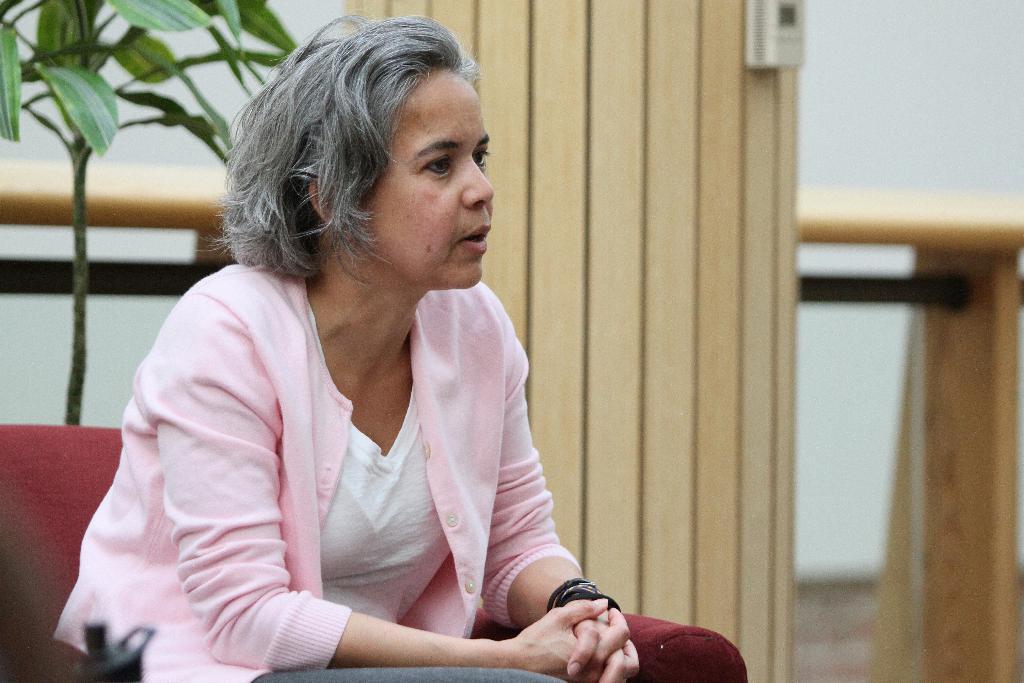Can you describe this image briefly? This is the woman sitting on the couch. She wore a jacket, T-shirt and trouser. This looks like a houseplant. I can see a wooden board. This looks like a table. 